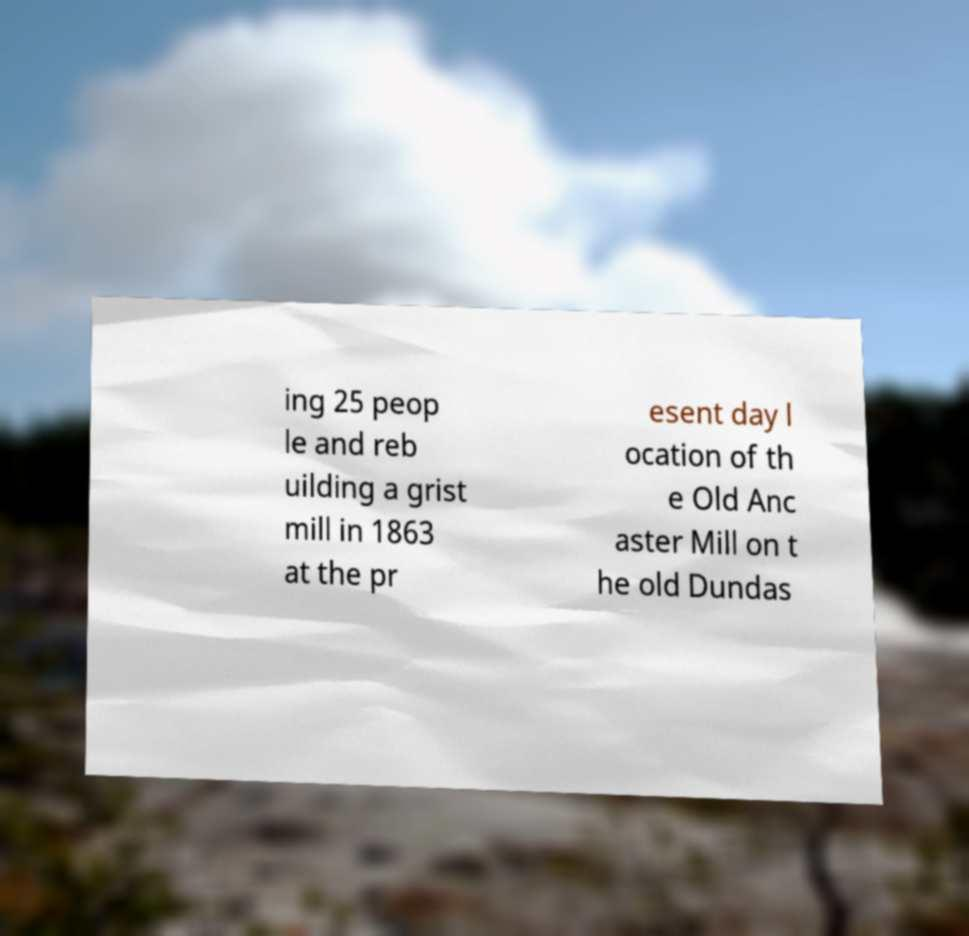Please identify and transcribe the text found in this image. ing 25 peop le and reb uilding a grist mill in 1863 at the pr esent day l ocation of th e Old Anc aster Mill on t he old Dundas 